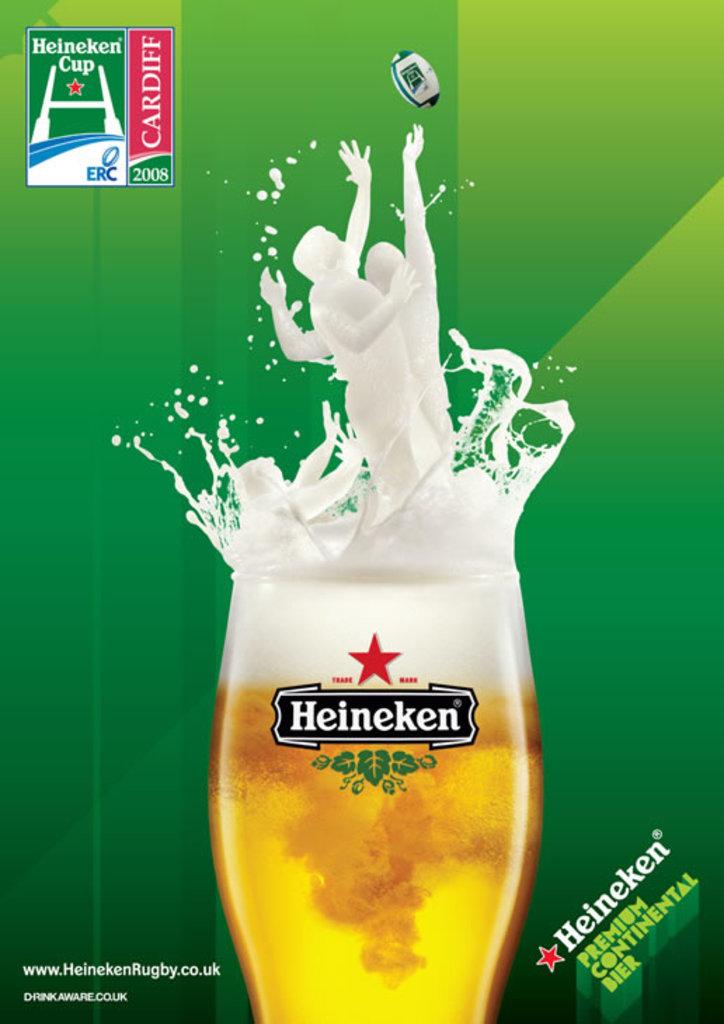What brand of beer is it?
Provide a succinct answer. Heineken. What type of beer is it?
Offer a very short reply. Heineken. 